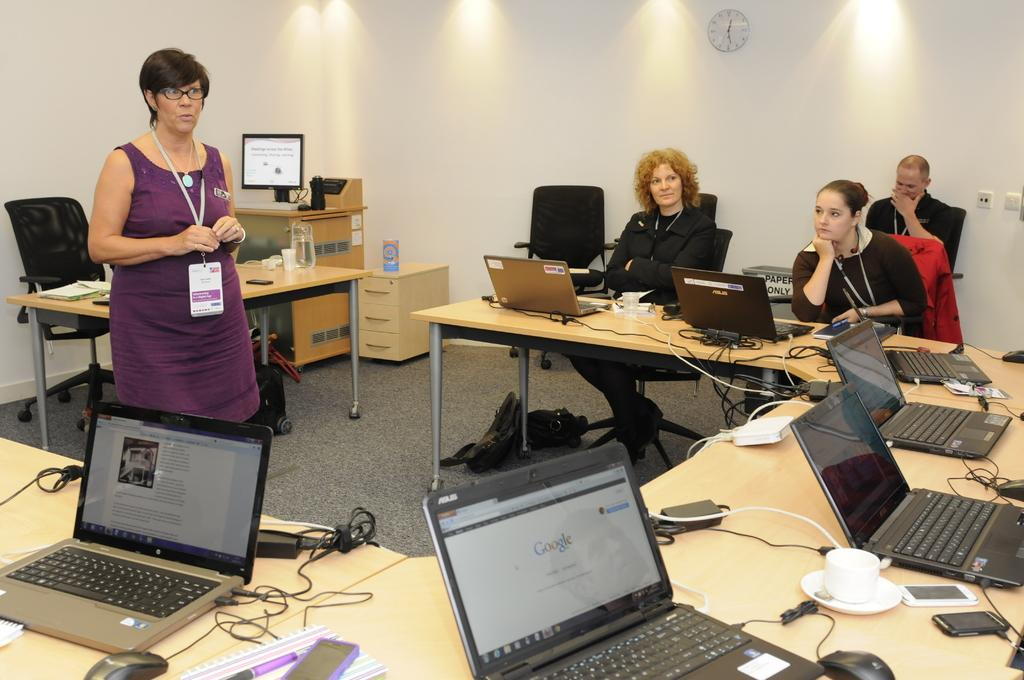<image>
Present a compact description of the photo's key features. People sit at tables around a woman, with their computers open to Google and other webpages. 